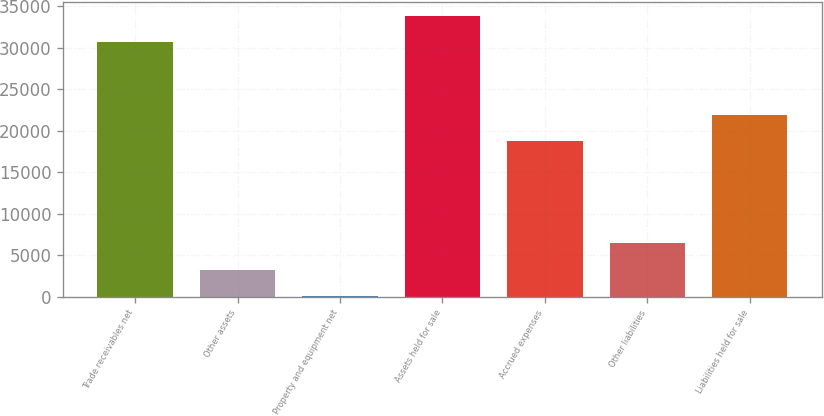<chart> <loc_0><loc_0><loc_500><loc_500><bar_chart><fcel>Trade receivables net<fcel>Other assets<fcel>Property and equipment net<fcel>Assets held for sale<fcel>Accrued expenses<fcel>Other liabilities<fcel>Liabilities held for sale<nl><fcel>30663<fcel>3242<fcel>45<fcel>33860<fcel>18738<fcel>6439<fcel>21935<nl></chart> 